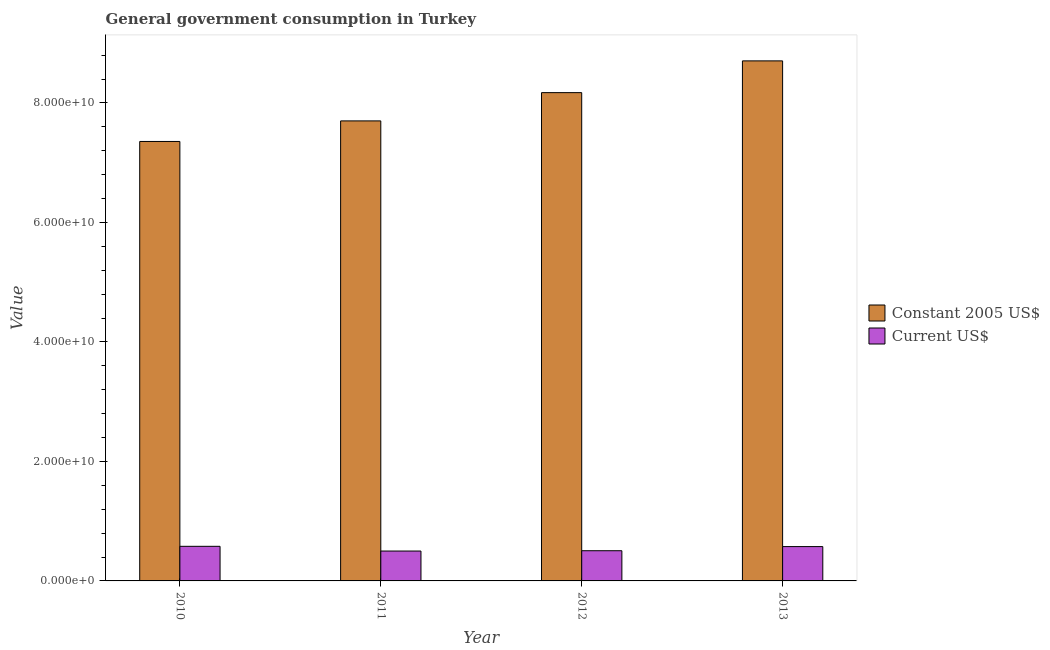How many different coloured bars are there?
Offer a terse response. 2. How many groups of bars are there?
Keep it short and to the point. 4. Are the number of bars per tick equal to the number of legend labels?
Your answer should be very brief. Yes. Are the number of bars on each tick of the X-axis equal?
Give a very brief answer. Yes. How many bars are there on the 2nd tick from the left?
Your response must be concise. 2. How many bars are there on the 1st tick from the right?
Provide a succinct answer. 2. What is the label of the 4th group of bars from the left?
Keep it short and to the point. 2013. What is the value consumed in current us$ in 2013?
Ensure brevity in your answer.  5.75e+09. Across all years, what is the maximum value consumed in current us$?
Keep it short and to the point. 5.79e+09. Across all years, what is the minimum value consumed in current us$?
Provide a short and direct response. 5.00e+09. In which year was the value consumed in constant 2005 us$ minimum?
Give a very brief answer. 2010. What is the total value consumed in current us$ in the graph?
Keep it short and to the point. 2.16e+1. What is the difference between the value consumed in current us$ in 2011 and that in 2012?
Your answer should be very brief. -5.25e+07. What is the difference between the value consumed in current us$ in 2013 and the value consumed in constant 2005 us$ in 2010?
Keep it short and to the point. -4.42e+07. What is the average value consumed in constant 2005 us$ per year?
Give a very brief answer. 7.98e+1. In the year 2012, what is the difference between the value consumed in constant 2005 us$ and value consumed in current us$?
Your answer should be very brief. 0. What is the ratio of the value consumed in constant 2005 us$ in 2010 to that in 2013?
Your answer should be compact. 0.85. Is the value consumed in constant 2005 us$ in 2012 less than that in 2013?
Ensure brevity in your answer.  Yes. Is the difference between the value consumed in current us$ in 2010 and 2013 greater than the difference between the value consumed in constant 2005 us$ in 2010 and 2013?
Ensure brevity in your answer.  No. What is the difference between the highest and the second highest value consumed in constant 2005 us$?
Your answer should be compact. 5.31e+09. What is the difference between the highest and the lowest value consumed in constant 2005 us$?
Give a very brief answer. 1.35e+1. Is the sum of the value consumed in current us$ in 2011 and 2012 greater than the maximum value consumed in constant 2005 us$ across all years?
Give a very brief answer. Yes. What does the 2nd bar from the left in 2012 represents?
Your answer should be compact. Current US$. What does the 2nd bar from the right in 2012 represents?
Your response must be concise. Constant 2005 US$. What is the difference between two consecutive major ticks on the Y-axis?
Provide a succinct answer. 2.00e+1. Are the values on the major ticks of Y-axis written in scientific E-notation?
Keep it short and to the point. Yes. Does the graph contain grids?
Your answer should be very brief. No. What is the title of the graph?
Provide a short and direct response. General government consumption in Turkey. Does "Primary school" appear as one of the legend labels in the graph?
Give a very brief answer. No. What is the label or title of the X-axis?
Your answer should be very brief. Year. What is the label or title of the Y-axis?
Your answer should be compact. Value. What is the Value of Constant 2005 US$ in 2010?
Provide a succinct answer. 7.36e+1. What is the Value of Current US$ in 2010?
Your answer should be very brief. 5.79e+09. What is the Value in Constant 2005 US$ in 2011?
Your answer should be compact. 7.70e+1. What is the Value in Current US$ in 2011?
Make the answer very short. 5.00e+09. What is the Value in Constant 2005 US$ in 2012?
Keep it short and to the point. 8.17e+1. What is the Value in Current US$ in 2012?
Ensure brevity in your answer.  5.05e+09. What is the Value of Constant 2005 US$ in 2013?
Your answer should be compact. 8.70e+1. What is the Value in Current US$ in 2013?
Provide a short and direct response. 5.75e+09. Across all years, what is the maximum Value of Constant 2005 US$?
Provide a succinct answer. 8.70e+1. Across all years, what is the maximum Value of Current US$?
Your answer should be very brief. 5.79e+09. Across all years, what is the minimum Value in Constant 2005 US$?
Provide a short and direct response. 7.36e+1. Across all years, what is the minimum Value of Current US$?
Ensure brevity in your answer.  5.00e+09. What is the total Value in Constant 2005 US$ in the graph?
Your answer should be compact. 3.19e+11. What is the total Value in Current US$ in the graph?
Offer a terse response. 2.16e+1. What is the difference between the Value of Constant 2005 US$ in 2010 and that in 2011?
Offer a terse response. -3.44e+09. What is the difference between the Value in Current US$ in 2010 and that in 2011?
Keep it short and to the point. 7.90e+08. What is the difference between the Value in Constant 2005 US$ in 2010 and that in 2012?
Make the answer very short. -8.17e+09. What is the difference between the Value of Current US$ in 2010 and that in 2012?
Make the answer very short. 7.37e+08. What is the difference between the Value of Constant 2005 US$ in 2010 and that in 2013?
Your response must be concise. -1.35e+1. What is the difference between the Value in Current US$ in 2010 and that in 2013?
Make the answer very short. 4.42e+07. What is the difference between the Value of Constant 2005 US$ in 2011 and that in 2012?
Give a very brief answer. -4.73e+09. What is the difference between the Value in Current US$ in 2011 and that in 2012?
Your response must be concise. -5.25e+07. What is the difference between the Value in Constant 2005 US$ in 2011 and that in 2013?
Ensure brevity in your answer.  -1.00e+1. What is the difference between the Value of Current US$ in 2011 and that in 2013?
Provide a short and direct response. -7.46e+08. What is the difference between the Value of Constant 2005 US$ in 2012 and that in 2013?
Keep it short and to the point. -5.31e+09. What is the difference between the Value in Current US$ in 2012 and that in 2013?
Offer a very short reply. -6.93e+08. What is the difference between the Value in Constant 2005 US$ in 2010 and the Value in Current US$ in 2011?
Keep it short and to the point. 6.85e+1. What is the difference between the Value of Constant 2005 US$ in 2010 and the Value of Current US$ in 2012?
Ensure brevity in your answer.  6.85e+1. What is the difference between the Value of Constant 2005 US$ in 2010 and the Value of Current US$ in 2013?
Provide a succinct answer. 6.78e+1. What is the difference between the Value in Constant 2005 US$ in 2011 and the Value in Current US$ in 2012?
Keep it short and to the point. 7.19e+1. What is the difference between the Value in Constant 2005 US$ in 2011 and the Value in Current US$ in 2013?
Provide a succinct answer. 7.12e+1. What is the difference between the Value in Constant 2005 US$ in 2012 and the Value in Current US$ in 2013?
Make the answer very short. 7.60e+1. What is the average Value of Constant 2005 US$ per year?
Offer a very short reply. 7.98e+1. What is the average Value in Current US$ per year?
Give a very brief answer. 5.40e+09. In the year 2010, what is the difference between the Value of Constant 2005 US$ and Value of Current US$?
Keep it short and to the point. 6.78e+1. In the year 2011, what is the difference between the Value in Constant 2005 US$ and Value in Current US$?
Make the answer very short. 7.20e+1. In the year 2012, what is the difference between the Value in Constant 2005 US$ and Value in Current US$?
Give a very brief answer. 7.67e+1. In the year 2013, what is the difference between the Value in Constant 2005 US$ and Value in Current US$?
Your response must be concise. 8.13e+1. What is the ratio of the Value of Constant 2005 US$ in 2010 to that in 2011?
Ensure brevity in your answer.  0.96. What is the ratio of the Value in Current US$ in 2010 to that in 2011?
Ensure brevity in your answer.  1.16. What is the ratio of the Value of Constant 2005 US$ in 2010 to that in 2012?
Keep it short and to the point. 0.9. What is the ratio of the Value of Current US$ in 2010 to that in 2012?
Provide a short and direct response. 1.15. What is the ratio of the Value of Constant 2005 US$ in 2010 to that in 2013?
Your answer should be compact. 0.85. What is the ratio of the Value of Current US$ in 2010 to that in 2013?
Offer a terse response. 1.01. What is the ratio of the Value in Constant 2005 US$ in 2011 to that in 2012?
Give a very brief answer. 0.94. What is the ratio of the Value in Current US$ in 2011 to that in 2012?
Offer a very short reply. 0.99. What is the ratio of the Value of Constant 2005 US$ in 2011 to that in 2013?
Make the answer very short. 0.88. What is the ratio of the Value of Current US$ in 2011 to that in 2013?
Offer a very short reply. 0.87. What is the ratio of the Value in Constant 2005 US$ in 2012 to that in 2013?
Give a very brief answer. 0.94. What is the ratio of the Value in Current US$ in 2012 to that in 2013?
Your answer should be compact. 0.88. What is the difference between the highest and the second highest Value of Constant 2005 US$?
Offer a terse response. 5.31e+09. What is the difference between the highest and the second highest Value in Current US$?
Your answer should be very brief. 4.42e+07. What is the difference between the highest and the lowest Value in Constant 2005 US$?
Keep it short and to the point. 1.35e+1. What is the difference between the highest and the lowest Value of Current US$?
Your response must be concise. 7.90e+08. 